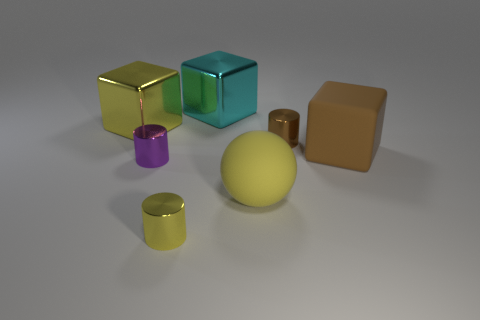Add 1 large balls. How many objects exist? 8 Subtract all spheres. How many objects are left? 6 Add 6 brown objects. How many brown objects exist? 8 Subtract 1 purple cylinders. How many objects are left? 6 Subtract all tiny brown rubber cylinders. Subtract all small purple metal cylinders. How many objects are left? 6 Add 2 yellow metal cylinders. How many yellow metal cylinders are left? 3 